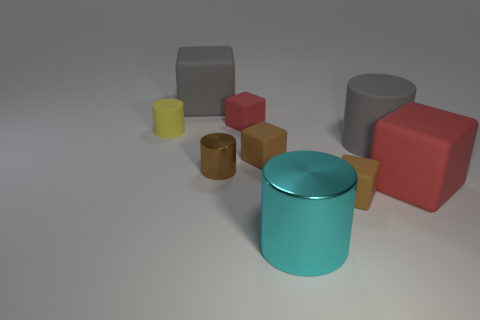Subtract 1 blocks. How many blocks are left? 4 Subtract all large gray blocks. How many blocks are left? 4 Subtract all gray cubes. How many cubes are left? 4 Subtract all purple blocks. Subtract all cyan balls. How many blocks are left? 5 Add 1 purple cubes. How many objects exist? 10 Subtract all blocks. How many objects are left? 4 Add 5 big matte cylinders. How many big matte cylinders are left? 6 Add 3 red shiny cubes. How many red shiny cubes exist? 3 Subtract 0 blue blocks. How many objects are left? 9 Subtract all gray things. Subtract all gray cylinders. How many objects are left? 6 